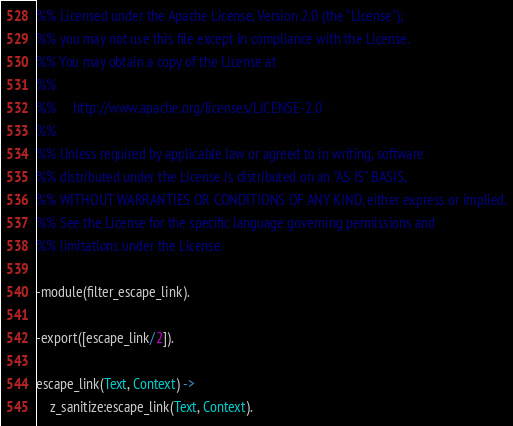Convert code to text. <code><loc_0><loc_0><loc_500><loc_500><_Erlang_>%% Licensed under the Apache License, Version 2.0 (the "License");
%% you may not use this file except in compliance with the License.
%% You may obtain a copy of the License at
%%
%%     http://www.apache.org/licenses/LICENSE-2.0
%%
%% Unless required by applicable law or agreed to in writing, software
%% distributed under the License is distributed on an "AS IS" BASIS,
%% WITHOUT WARRANTIES OR CONDITIONS OF ANY KIND, either express or implied.
%% See the License for the specific language governing permissions and
%% limitations under the License.

-module(filter_escape_link).

-export([escape_link/2]).

escape_link(Text, Context) ->
    z_sanitize:escape_link(Text, Context).

</code> 